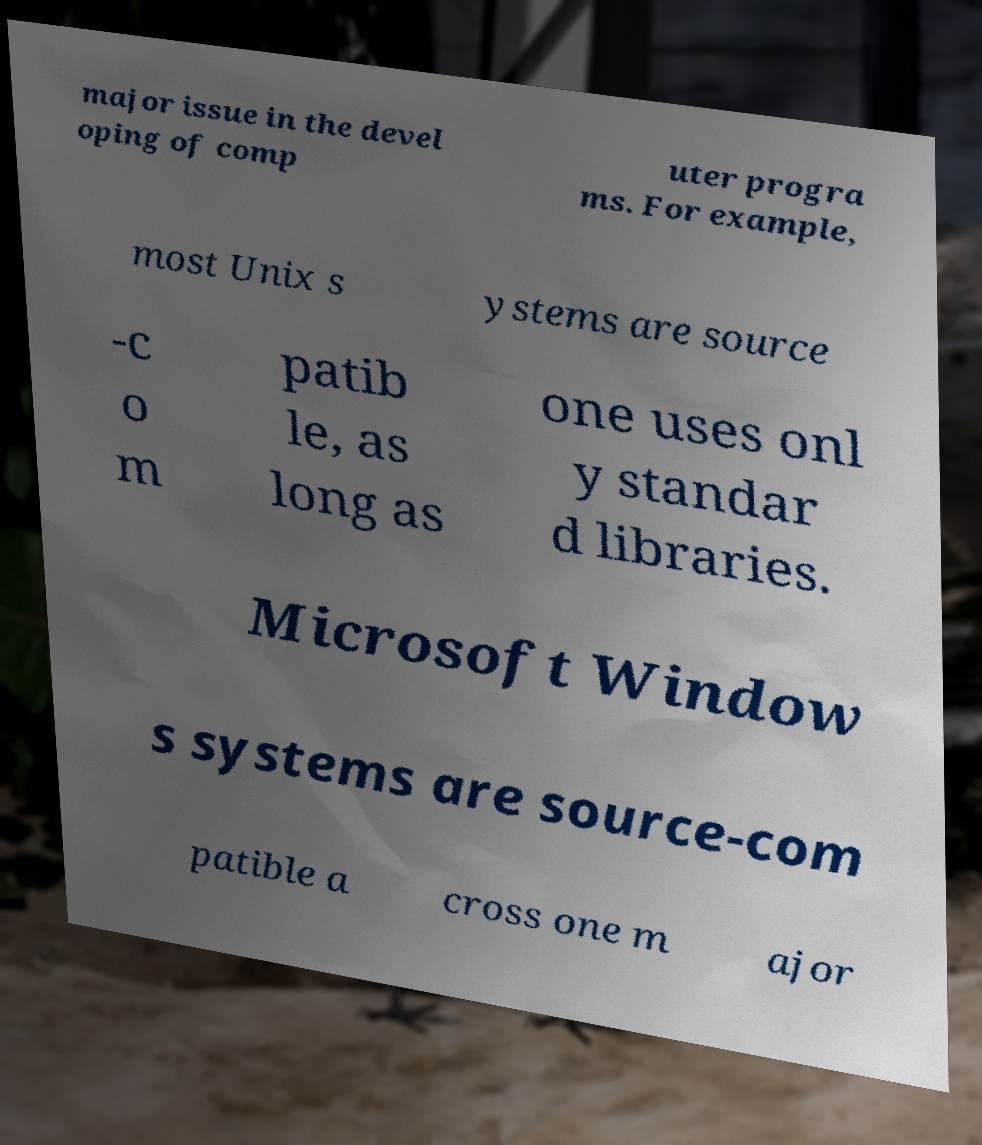Can you read and provide the text displayed in the image?This photo seems to have some interesting text. Can you extract and type it out for me? major issue in the devel oping of comp uter progra ms. For example, most Unix s ystems are source -c o m patib le, as long as one uses onl y standar d libraries. Microsoft Window s systems are source-com patible a cross one m ajor 